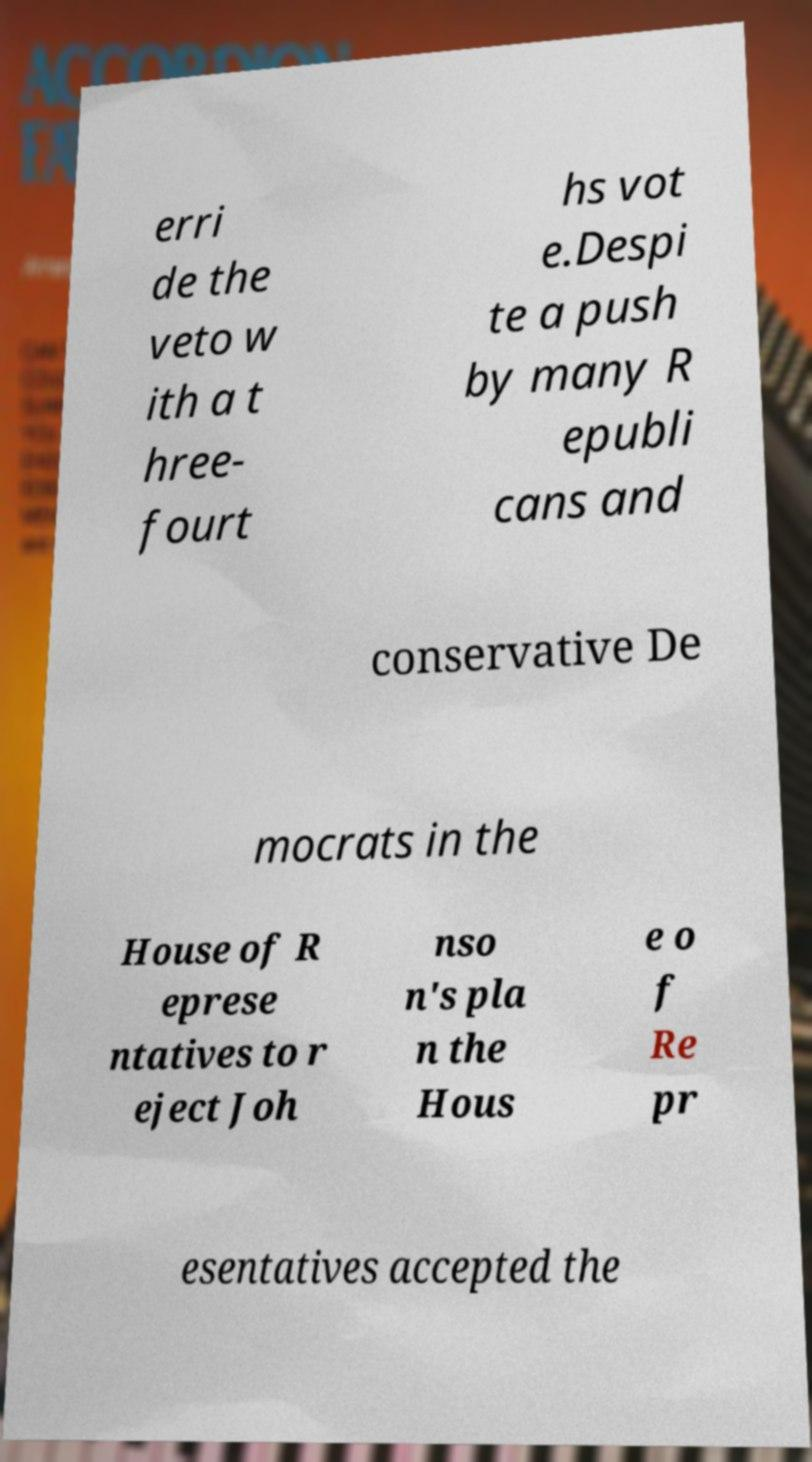There's text embedded in this image that I need extracted. Can you transcribe it verbatim? erri de the veto w ith a t hree- fourt hs vot e.Despi te a push by many R epubli cans and conservative De mocrats in the House of R eprese ntatives to r eject Joh nso n's pla n the Hous e o f Re pr esentatives accepted the 